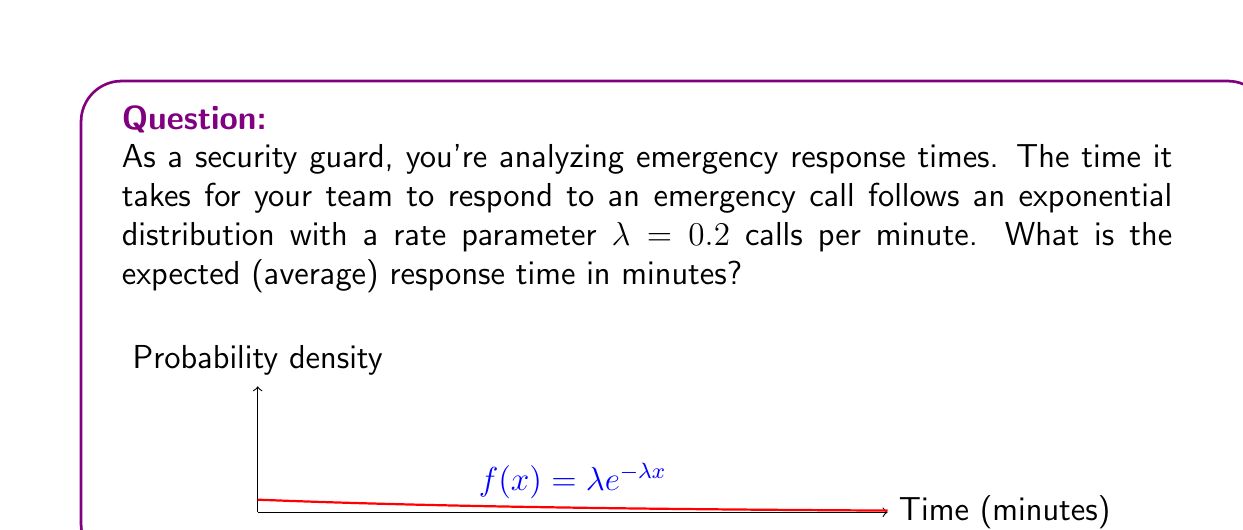Can you answer this question? Let's approach this step-by-step:

1) For an exponential distribution, the expected value (mean) is given by:

   $$E[X] = \frac{1}{\lambda}$$

   where $\lambda$ is the rate parameter.

2) We're given that $\lambda = 0.2$ calls per minute.

3) Substituting this into our formula:

   $$E[X] = \frac{1}{0.2}$$

4) Simplifying:

   $$E[X] = 5$$

5) Therefore, the expected response time is 5 minutes.

This means that, on average, it takes your security team 5 minutes to respond to an emergency call. Understanding this can help in planning and improving response strategies.
Answer: 5 minutes 